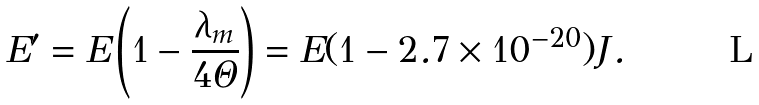<formula> <loc_0><loc_0><loc_500><loc_500>E ^ { \prime } = E \left ( 1 - \frac { \lambda _ { m } } { 4 \Theta } \right ) = E ( 1 - 2 . 7 \times 1 0 ^ { - 2 0 } ) J .</formula> 